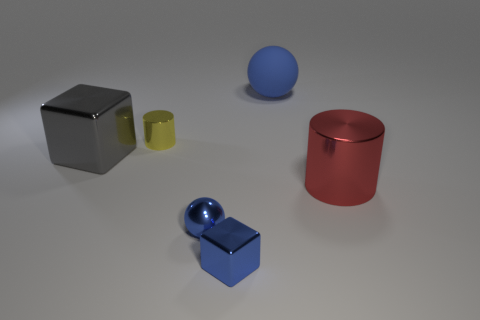How many other tiny metal things have the same shape as the yellow metal thing?
Give a very brief answer. 0. There is a small thing that is the same color as the tiny ball; what is its material?
Give a very brief answer. Metal. Is the size of the cylinder behind the big gray thing the same as the block that is behind the small blue metallic ball?
Provide a short and direct response. No. The blue thing that is in front of the blue shiny ball has what shape?
Give a very brief answer. Cube. There is a rubber ball that is behind the metallic sphere; does it have the same size as the big gray thing?
Offer a very short reply. Yes. What number of cubes are right of the small yellow shiny cylinder?
Make the answer very short. 1. Is the number of balls behind the yellow metal cylinder less than the number of tiny metallic objects that are in front of the gray metal thing?
Your answer should be compact. Yes. How many matte things are there?
Offer a terse response. 1. There is a cube that is behind the big red shiny object; what color is it?
Provide a succinct answer. Gray. What size is the gray metallic thing?
Offer a very short reply. Large. 